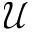<formula> <loc_0><loc_0><loc_500><loc_500>\mathcal { U }</formula> 